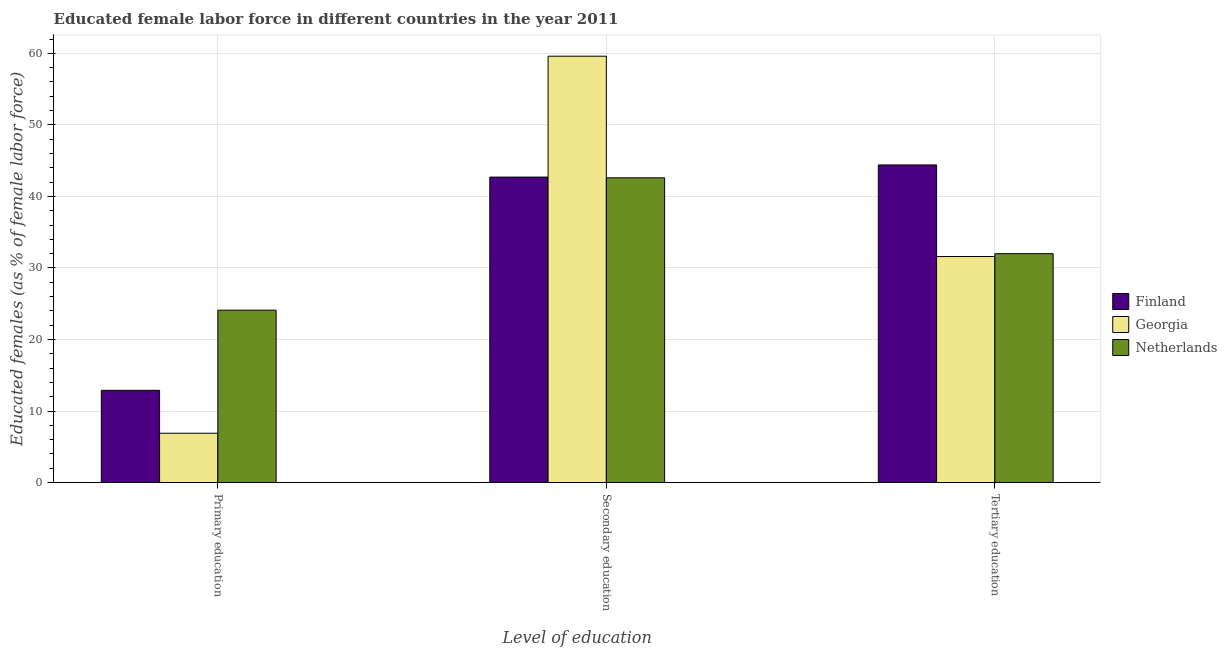How many groups of bars are there?
Your response must be concise. 3. How many bars are there on the 1st tick from the left?
Your response must be concise. 3. How many bars are there on the 2nd tick from the right?
Offer a very short reply. 3. What is the label of the 3rd group of bars from the left?
Make the answer very short. Tertiary education. What is the percentage of female labor force who received tertiary education in Finland?
Make the answer very short. 44.4. Across all countries, what is the maximum percentage of female labor force who received secondary education?
Offer a terse response. 59.6. Across all countries, what is the minimum percentage of female labor force who received tertiary education?
Your answer should be compact. 31.6. In which country was the percentage of female labor force who received tertiary education maximum?
Offer a terse response. Finland. In which country was the percentage of female labor force who received secondary education minimum?
Your answer should be very brief. Netherlands. What is the total percentage of female labor force who received tertiary education in the graph?
Make the answer very short. 108. What is the difference between the percentage of female labor force who received primary education in Georgia and the percentage of female labor force who received tertiary education in Netherlands?
Offer a very short reply. -25.1. What is the average percentage of female labor force who received primary education per country?
Offer a very short reply. 14.63. What is the difference between the percentage of female labor force who received secondary education and percentage of female labor force who received primary education in Finland?
Offer a very short reply. 29.8. What is the ratio of the percentage of female labor force who received primary education in Finland to that in Netherlands?
Make the answer very short. 0.54. Is the percentage of female labor force who received primary education in Finland less than that in Georgia?
Offer a terse response. No. Is the difference between the percentage of female labor force who received tertiary education in Netherlands and Georgia greater than the difference between the percentage of female labor force who received secondary education in Netherlands and Georgia?
Your answer should be very brief. Yes. What is the difference between the highest and the second highest percentage of female labor force who received tertiary education?
Provide a short and direct response. 12.4. What is the difference between the highest and the lowest percentage of female labor force who received secondary education?
Offer a very short reply. 17. Is the sum of the percentage of female labor force who received tertiary education in Georgia and Finland greater than the maximum percentage of female labor force who received secondary education across all countries?
Offer a terse response. Yes. What does the 1st bar from the left in Tertiary education represents?
Provide a short and direct response. Finland. What does the 2nd bar from the right in Primary education represents?
Provide a succinct answer. Georgia. How many bars are there?
Provide a succinct answer. 9. Are the values on the major ticks of Y-axis written in scientific E-notation?
Provide a succinct answer. No. Does the graph contain any zero values?
Keep it short and to the point. No. Does the graph contain grids?
Give a very brief answer. Yes. How many legend labels are there?
Give a very brief answer. 3. How are the legend labels stacked?
Your answer should be very brief. Vertical. What is the title of the graph?
Make the answer very short. Educated female labor force in different countries in the year 2011. Does "Bhutan" appear as one of the legend labels in the graph?
Provide a short and direct response. No. What is the label or title of the X-axis?
Your answer should be very brief. Level of education. What is the label or title of the Y-axis?
Make the answer very short. Educated females (as % of female labor force). What is the Educated females (as % of female labor force) in Finland in Primary education?
Your response must be concise. 12.9. What is the Educated females (as % of female labor force) of Georgia in Primary education?
Your response must be concise. 6.9. What is the Educated females (as % of female labor force) of Netherlands in Primary education?
Ensure brevity in your answer.  24.1. What is the Educated females (as % of female labor force) of Finland in Secondary education?
Your answer should be very brief. 42.7. What is the Educated females (as % of female labor force) in Georgia in Secondary education?
Offer a terse response. 59.6. What is the Educated females (as % of female labor force) of Netherlands in Secondary education?
Give a very brief answer. 42.6. What is the Educated females (as % of female labor force) of Finland in Tertiary education?
Ensure brevity in your answer.  44.4. What is the Educated females (as % of female labor force) in Georgia in Tertiary education?
Offer a very short reply. 31.6. Across all Level of education, what is the maximum Educated females (as % of female labor force) in Finland?
Your response must be concise. 44.4. Across all Level of education, what is the maximum Educated females (as % of female labor force) of Georgia?
Your response must be concise. 59.6. Across all Level of education, what is the maximum Educated females (as % of female labor force) in Netherlands?
Your answer should be compact. 42.6. Across all Level of education, what is the minimum Educated females (as % of female labor force) of Finland?
Your answer should be very brief. 12.9. Across all Level of education, what is the minimum Educated females (as % of female labor force) in Georgia?
Your answer should be compact. 6.9. Across all Level of education, what is the minimum Educated females (as % of female labor force) in Netherlands?
Your response must be concise. 24.1. What is the total Educated females (as % of female labor force) of Georgia in the graph?
Give a very brief answer. 98.1. What is the total Educated females (as % of female labor force) in Netherlands in the graph?
Offer a terse response. 98.7. What is the difference between the Educated females (as % of female labor force) of Finland in Primary education and that in Secondary education?
Your response must be concise. -29.8. What is the difference between the Educated females (as % of female labor force) in Georgia in Primary education and that in Secondary education?
Offer a terse response. -52.7. What is the difference between the Educated females (as % of female labor force) of Netherlands in Primary education and that in Secondary education?
Provide a succinct answer. -18.5. What is the difference between the Educated females (as % of female labor force) of Finland in Primary education and that in Tertiary education?
Offer a very short reply. -31.5. What is the difference between the Educated females (as % of female labor force) in Georgia in Primary education and that in Tertiary education?
Keep it short and to the point. -24.7. What is the difference between the Educated females (as % of female labor force) in Finland in Secondary education and that in Tertiary education?
Your answer should be compact. -1.7. What is the difference between the Educated females (as % of female labor force) of Georgia in Secondary education and that in Tertiary education?
Give a very brief answer. 28. What is the difference between the Educated females (as % of female labor force) of Netherlands in Secondary education and that in Tertiary education?
Offer a terse response. 10.6. What is the difference between the Educated females (as % of female labor force) of Finland in Primary education and the Educated females (as % of female labor force) of Georgia in Secondary education?
Provide a succinct answer. -46.7. What is the difference between the Educated females (as % of female labor force) of Finland in Primary education and the Educated females (as % of female labor force) of Netherlands in Secondary education?
Offer a very short reply. -29.7. What is the difference between the Educated females (as % of female labor force) in Georgia in Primary education and the Educated females (as % of female labor force) in Netherlands in Secondary education?
Offer a terse response. -35.7. What is the difference between the Educated females (as % of female labor force) of Finland in Primary education and the Educated females (as % of female labor force) of Georgia in Tertiary education?
Make the answer very short. -18.7. What is the difference between the Educated females (as % of female labor force) of Finland in Primary education and the Educated females (as % of female labor force) of Netherlands in Tertiary education?
Provide a succinct answer. -19.1. What is the difference between the Educated females (as % of female labor force) of Georgia in Primary education and the Educated females (as % of female labor force) of Netherlands in Tertiary education?
Ensure brevity in your answer.  -25.1. What is the difference between the Educated females (as % of female labor force) of Finland in Secondary education and the Educated females (as % of female labor force) of Netherlands in Tertiary education?
Your answer should be very brief. 10.7. What is the difference between the Educated females (as % of female labor force) of Georgia in Secondary education and the Educated females (as % of female labor force) of Netherlands in Tertiary education?
Your response must be concise. 27.6. What is the average Educated females (as % of female labor force) of Finland per Level of education?
Offer a terse response. 33.33. What is the average Educated females (as % of female labor force) in Georgia per Level of education?
Your response must be concise. 32.7. What is the average Educated females (as % of female labor force) in Netherlands per Level of education?
Give a very brief answer. 32.9. What is the difference between the Educated females (as % of female labor force) in Finland and Educated females (as % of female labor force) in Georgia in Primary education?
Your answer should be compact. 6. What is the difference between the Educated females (as % of female labor force) in Finland and Educated females (as % of female labor force) in Netherlands in Primary education?
Provide a succinct answer. -11.2. What is the difference between the Educated females (as % of female labor force) in Georgia and Educated females (as % of female labor force) in Netherlands in Primary education?
Offer a terse response. -17.2. What is the difference between the Educated females (as % of female labor force) in Finland and Educated females (as % of female labor force) in Georgia in Secondary education?
Offer a very short reply. -16.9. What is the difference between the Educated females (as % of female labor force) in Finland and Educated females (as % of female labor force) in Netherlands in Secondary education?
Give a very brief answer. 0.1. What is the difference between the Educated females (as % of female labor force) in Finland and Educated females (as % of female labor force) in Netherlands in Tertiary education?
Provide a succinct answer. 12.4. What is the difference between the Educated females (as % of female labor force) of Georgia and Educated females (as % of female labor force) of Netherlands in Tertiary education?
Make the answer very short. -0.4. What is the ratio of the Educated females (as % of female labor force) of Finland in Primary education to that in Secondary education?
Ensure brevity in your answer.  0.3. What is the ratio of the Educated females (as % of female labor force) in Georgia in Primary education to that in Secondary education?
Give a very brief answer. 0.12. What is the ratio of the Educated females (as % of female labor force) in Netherlands in Primary education to that in Secondary education?
Your answer should be compact. 0.57. What is the ratio of the Educated females (as % of female labor force) in Finland in Primary education to that in Tertiary education?
Give a very brief answer. 0.29. What is the ratio of the Educated females (as % of female labor force) of Georgia in Primary education to that in Tertiary education?
Offer a terse response. 0.22. What is the ratio of the Educated females (as % of female labor force) in Netherlands in Primary education to that in Tertiary education?
Ensure brevity in your answer.  0.75. What is the ratio of the Educated females (as % of female labor force) of Finland in Secondary education to that in Tertiary education?
Your response must be concise. 0.96. What is the ratio of the Educated females (as % of female labor force) in Georgia in Secondary education to that in Tertiary education?
Offer a terse response. 1.89. What is the ratio of the Educated females (as % of female labor force) of Netherlands in Secondary education to that in Tertiary education?
Provide a short and direct response. 1.33. What is the difference between the highest and the second highest Educated females (as % of female labor force) in Finland?
Ensure brevity in your answer.  1.7. What is the difference between the highest and the second highest Educated females (as % of female labor force) of Georgia?
Make the answer very short. 28. What is the difference between the highest and the second highest Educated females (as % of female labor force) in Netherlands?
Make the answer very short. 10.6. What is the difference between the highest and the lowest Educated females (as % of female labor force) of Finland?
Your answer should be compact. 31.5. What is the difference between the highest and the lowest Educated females (as % of female labor force) of Georgia?
Keep it short and to the point. 52.7. 